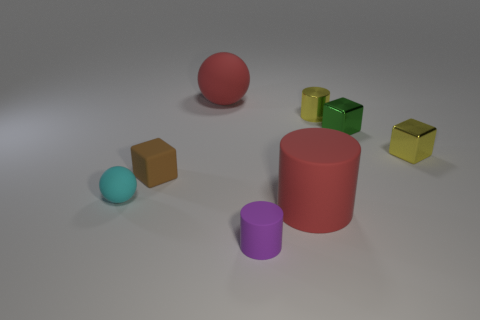Subtract all small shiny cubes. How many cubes are left? 1 Subtract 0 brown balls. How many objects are left? 8 Subtract all balls. How many objects are left? 6 Subtract 2 cubes. How many cubes are left? 1 Subtract all blue cylinders. Subtract all blue spheres. How many cylinders are left? 3 Subtract all cyan balls. How many purple cylinders are left? 1 Subtract all purple objects. Subtract all small purple objects. How many objects are left? 6 Add 8 green things. How many green things are left? 9 Add 2 cyan things. How many cyan things exist? 3 Add 2 big rubber cubes. How many objects exist? 10 